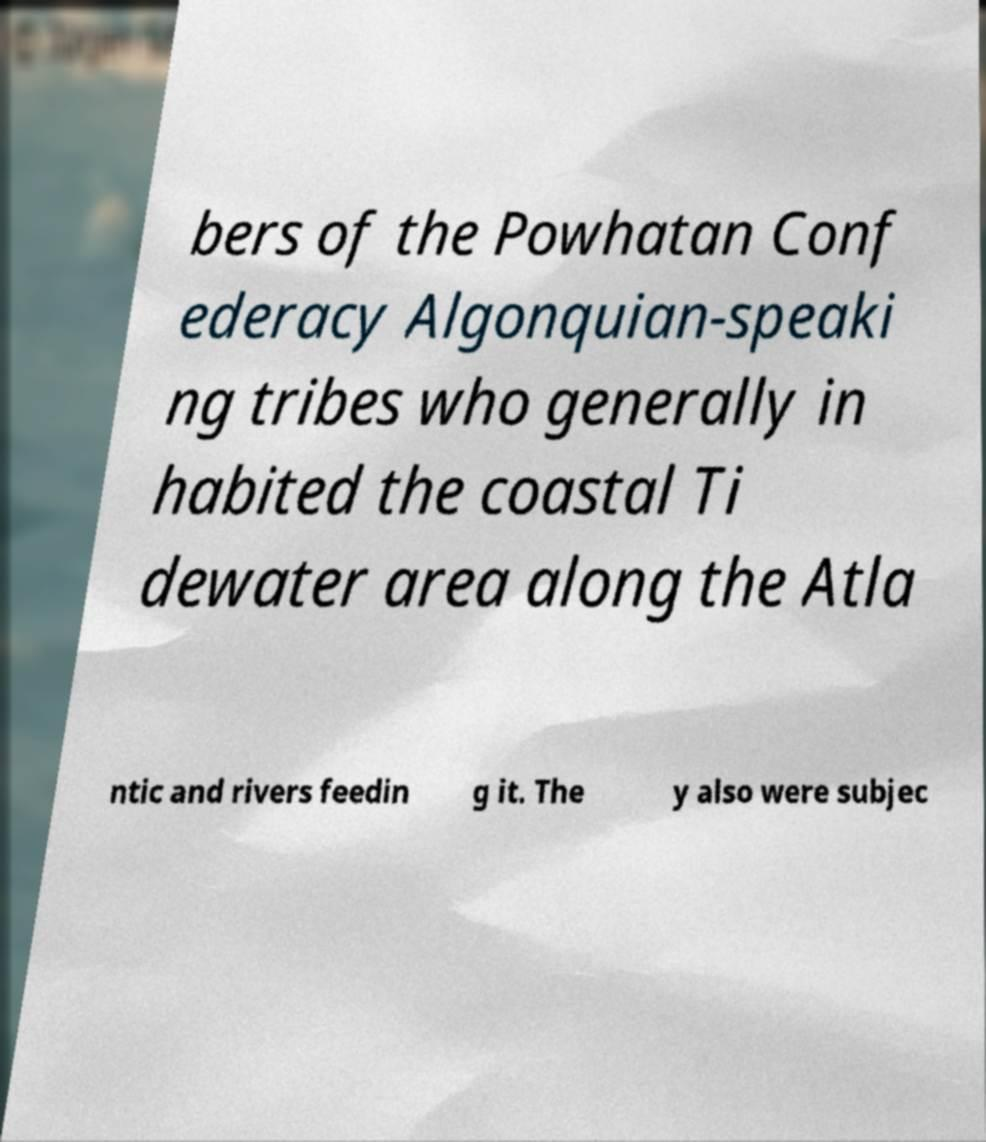Please identify and transcribe the text found in this image. bers of the Powhatan Conf ederacy Algonquian-speaki ng tribes who generally in habited the coastal Ti dewater area along the Atla ntic and rivers feedin g it. The y also were subjec 